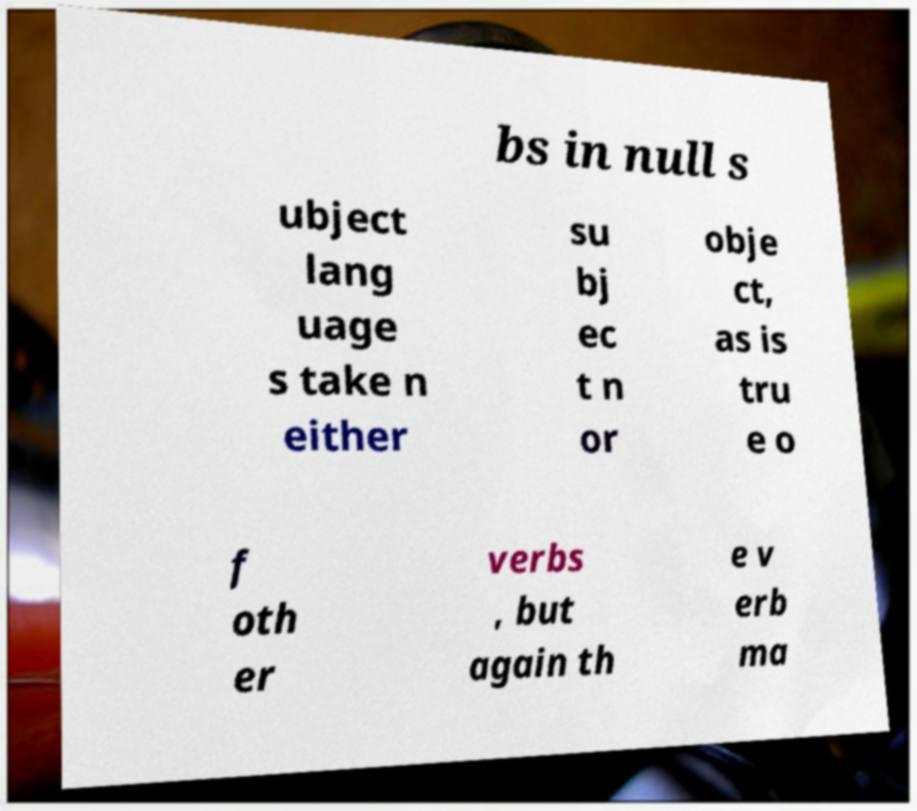What messages or text are displayed in this image? I need them in a readable, typed format. bs in null s ubject lang uage s take n either su bj ec t n or obje ct, as is tru e o f oth er verbs , but again th e v erb ma 